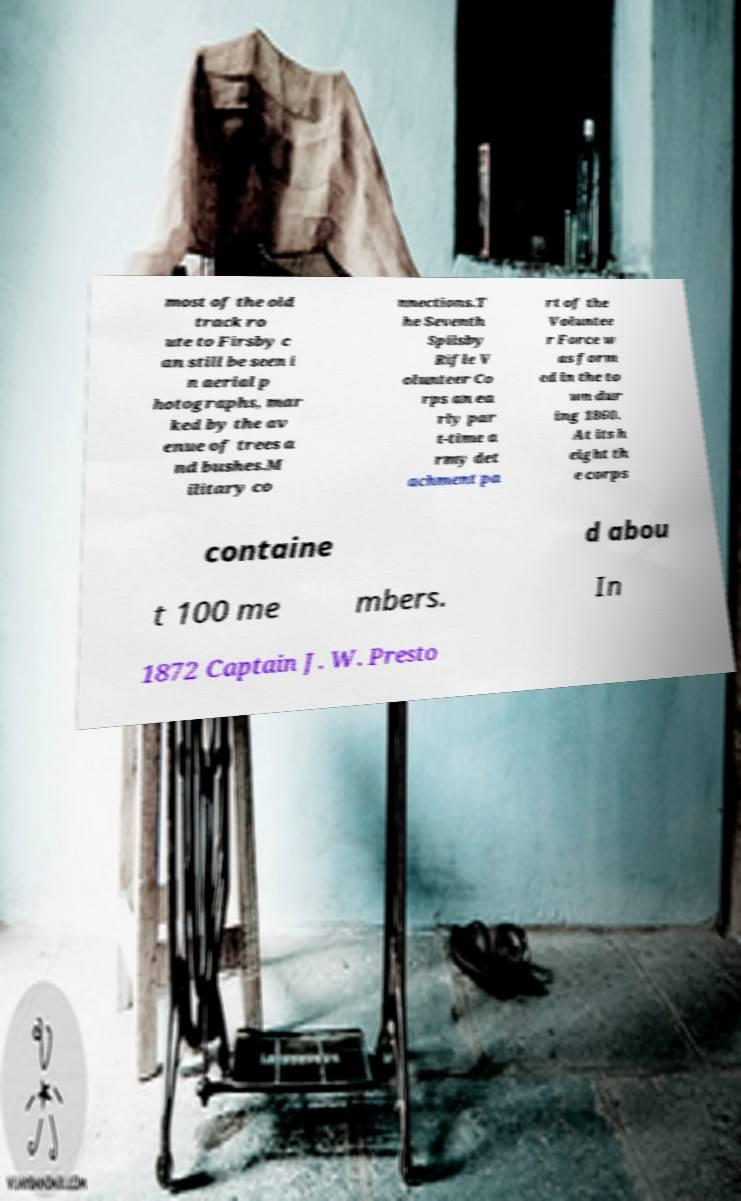Could you assist in decoding the text presented in this image and type it out clearly? most of the old track ro ute to Firsby c an still be seen i n aerial p hotographs, mar ked by the av enue of trees a nd bushes.M ilitary co nnections.T he Seventh Spilsby Rifle V olunteer Co rps an ea rly par t-time a rmy det achment pa rt of the Voluntee r Force w as form ed in the to wn dur ing 1860. At its h eight th e corps containe d abou t 100 me mbers. In 1872 Captain J. W. Presto 